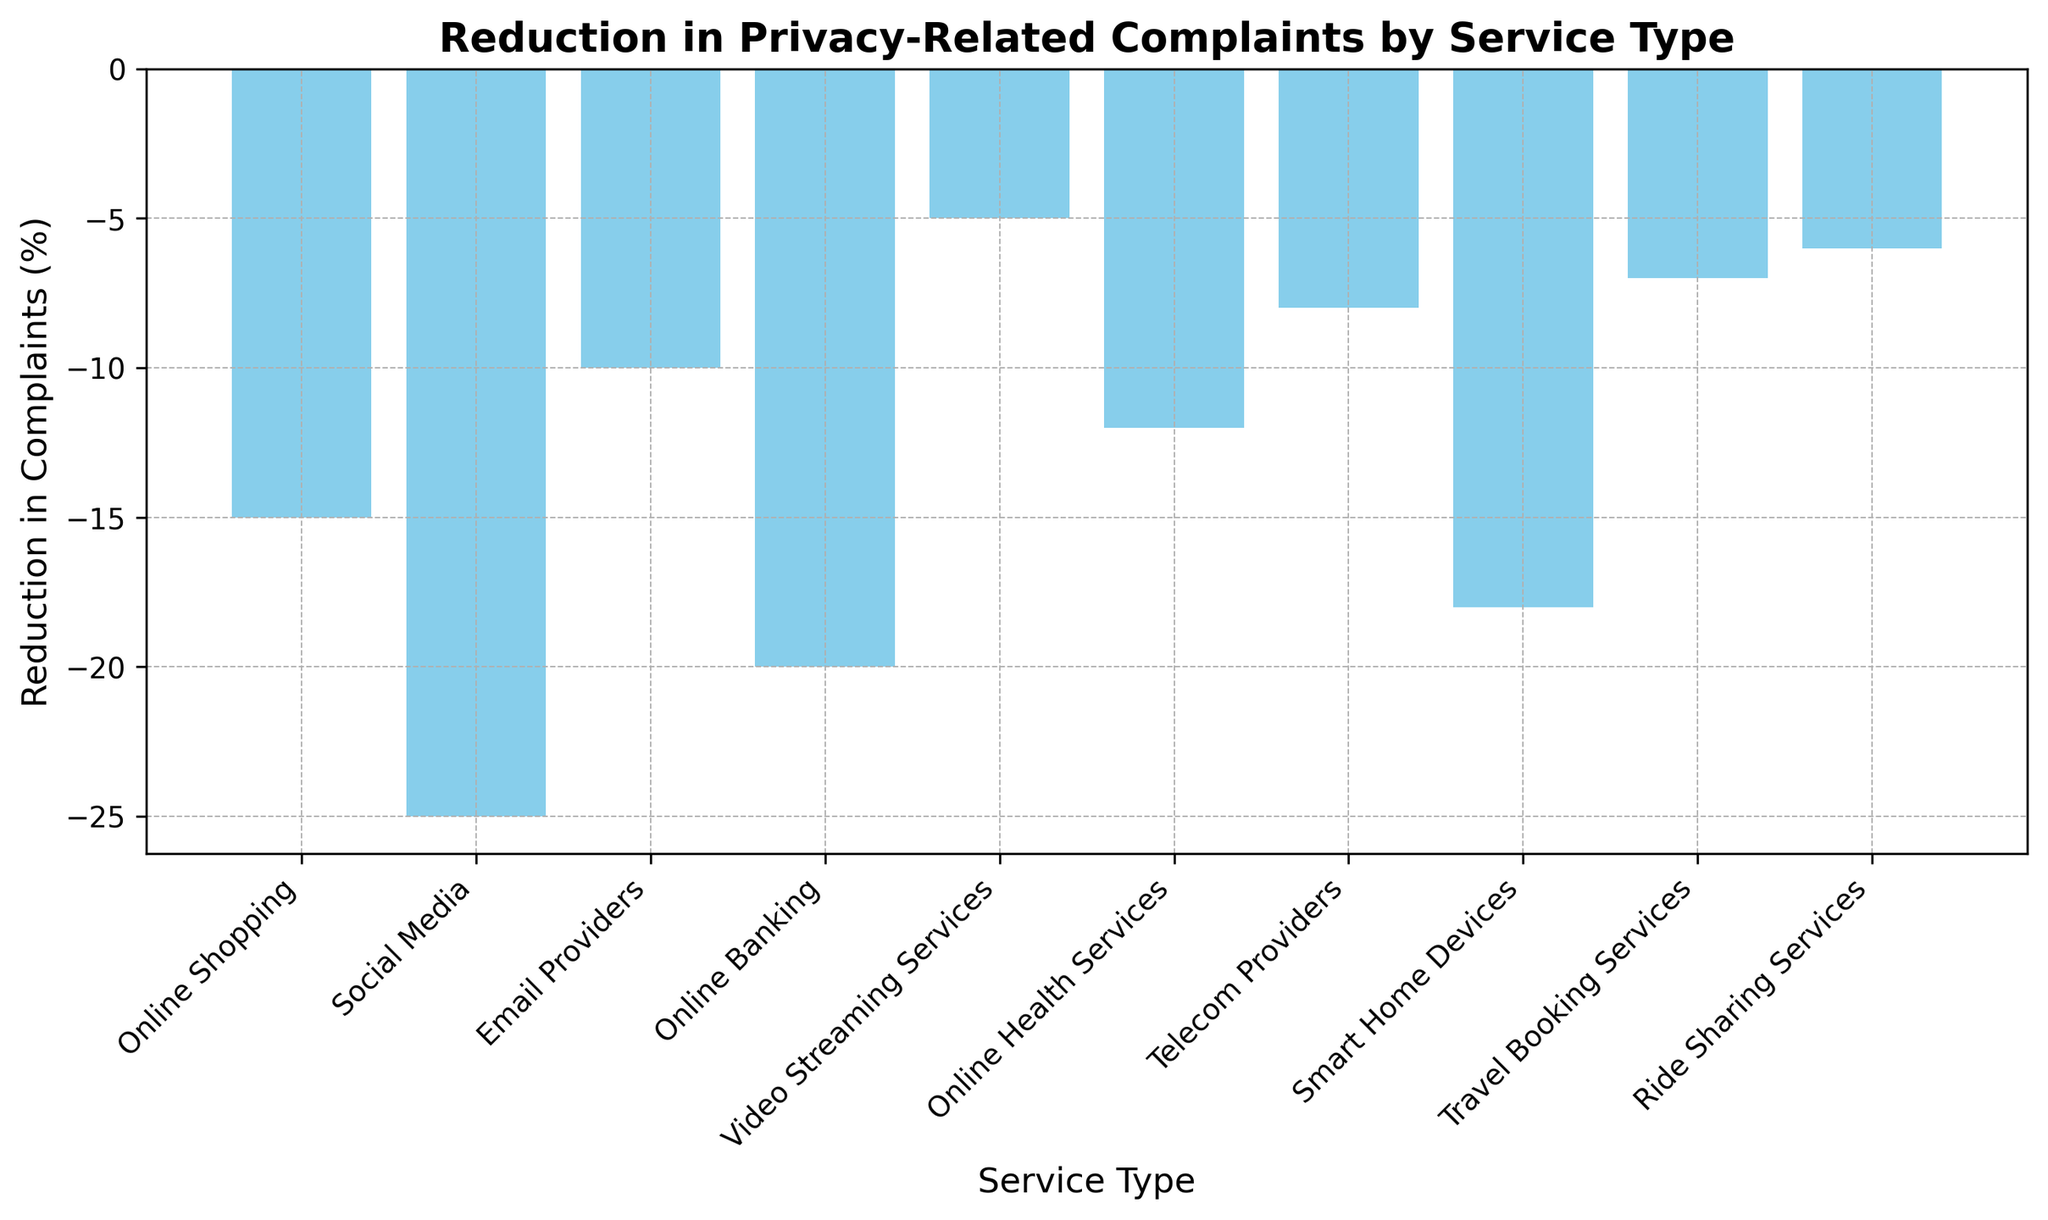Which service type has the highest reduction in complaints? Identify the bar with the tallest height in the negative direction. The "Social Media" bar has the greatest negative value, indicating the highest reduction in complaints.
Answer: Social Media Which service type has the lowest reduction in complaints? Look for the bar with the smallest negative height. The "Video Streaming Services" bar is the shortest, indicating the lowest reduction in complaints.
Answer: Video Streaming Services Which service types have reductions in complaints greater than -10? Examine the bars to find those with heights greater than -10. "Video Streaming Services", "Telecom Providers", "Travel Booking Services", and "Ride Sharing Services" all fall in this category.
Answer: Video Streaming Services, Telecom Providers, Travel Booking Services, Ride Sharing Services What is the total reduction in complaints for Online Shopping and Online Banking combined? Sum the reductions for both categories. Online Shopping has a reduction of -15, and Online Banking has -20. The total is -15 + (-20) = -35.
Answer: -35 How does the reduction in complaints for Smart Home Devices compare with Online Health Services? Compare the heights of the respective bars. Smart Home Devices have a reduction of -18, and Online Health Services have -12. Smart Home Devices have a greater reduction.
Answer: Smart Home Devices What is the average reduction in complaints across all service types? Add up all the reductions and divide by the number of service types. The reductions sum to -126 and there are 10 service types. The average reduction is -126 / 10 = -12.6.
Answer: -12.6 Which service types have a reduction in complaints between -15 and -10? Identify the bars that fall within this range. "Online Shopping", "Online Health Services", and "Smart Home Devices" have reductions in this range.
Answer: Online Shopping, Online Health Services, Smart Home Devices If you sum the reductions in complaints for Social Media and Online Banking, how does it compare to the reduction in Smart Home Devices? Calculate the sum of reductions for Social Media and Online Banking, then compare it to Smart Home Devices. Social Media and Online Banking together have -25 + (-20) = -45, which is larger than the -18 for Smart Home Devices.
Answer: Larger 